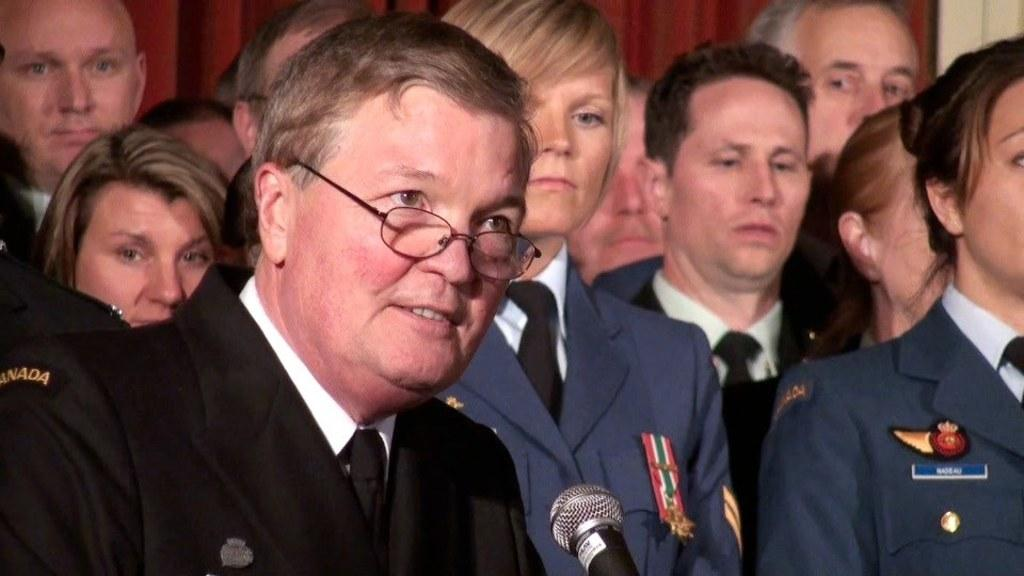How many people are in the image? There are a few people in the image. What is behind the people in the image? There is a wall behind the people. What object is in front of the people? There is a microphone (mic) in front of the people. What type of operation are the people attempting to perform with the microphone in the image? There is no indication of an operation or attempt to perform one in the image; the people are simply standing in front of the microphone. 